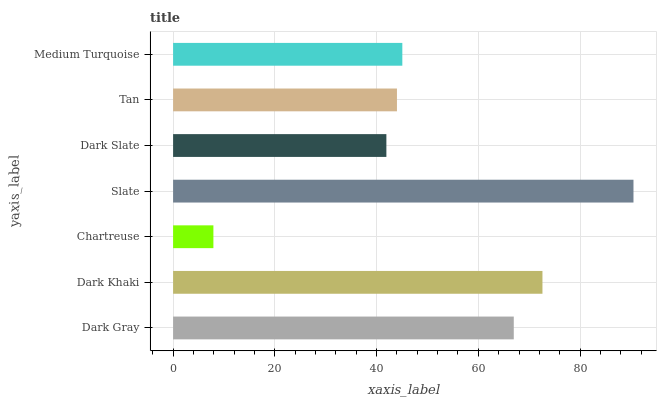Is Chartreuse the minimum?
Answer yes or no. Yes. Is Slate the maximum?
Answer yes or no. Yes. Is Dark Khaki the minimum?
Answer yes or no. No. Is Dark Khaki the maximum?
Answer yes or no. No. Is Dark Khaki greater than Dark Gray?
Answer yes or no. Yes. Is Dark Gray less than Dark Khaki?
Answer yes or no. Yes. Is Dark Gray greater than Dark Khaki?
Answer yes or no. No. Is Dark Khaki less than Dark Gray?
Answer yes or no. No. Is Medium Turquoise the high median?
Answer yes or no. Yes. Is Medium Turquoise the low median?
Answer yes or no. Yes. Is Dark Slate the high median?
Answer yes or no. No. Is Dark Khaki the low median?
Answer yes or no. No. 